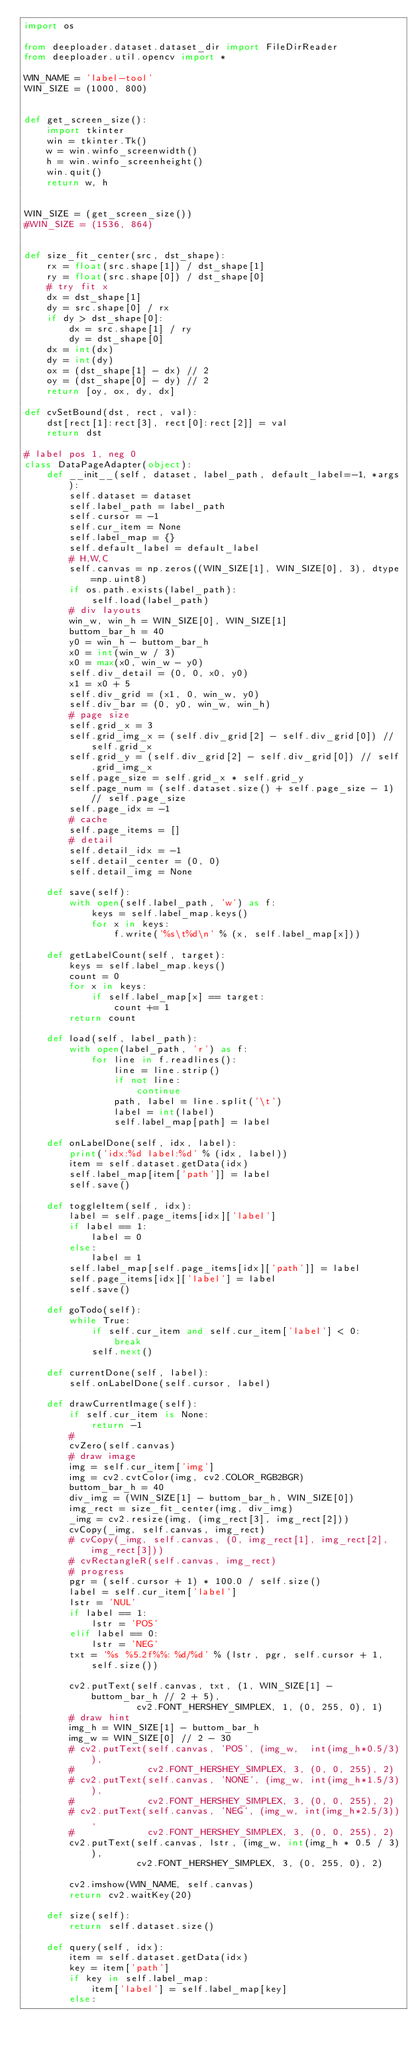Convert code to text. <code><loc_0><loc_0><loc_500><loc_500><_Python_>import os

from deeploader.dataset.dataset_dir import FileDirReader
from deeploader.util.opencv import *

WIN_NAME = 'label-tool'
WIN_SIZE = (1000, 800)


def get_screen_size():
    import tkinter
    win = tkinter.Tk()
    w = win.winfo_screenwidth()
    h = win.winfo_screenheight()
    win.quit()
    return w, h


WIN_SIZE = (get_screen_size())
#WIN_SIZE = (1536, 864)


def size_fit_center(src, dst_shape):
    rx = float(src.shape[1]) / dst_shape[1]
    ry = float(src.shape[0]) / dst_shape[0]
    # try fit x
    dx = dst_shape[1]
    dy = src.shape[0] / rx
    if dy > dst_shape[0]:
        dx = src.shape[1] / ry
        dy = dst_shape[0]
    dx = int(dx)
    dy = int(dy)
    ox = (dst_shape[1] - dx) // 2
    oy = (dst_shape[0] - dy) // 2
    return [oy, ox, dy, dx]

def cvSetBound(dst, rect, val):
    dst[rect[1]:rect[3], rect[0]:rect[2]] = val
    return dst

# label pos 1, neg 0
class DataPageAdapter(object):
    def __init__(self, dataset, label_path, default_label=-1, *args):
        self.dataset = dataset
        self.label_path = label_path
        self.cursor = -1
        self.cur_item = None
        self.label_map = {}
        self.default_label = default_label
        # H,W,C
        self.canvas = np.zeros((WIN_SIZE[1], WIN_SIZE[0], 3), dtype=np.uint8)
        if os.path.exists(label_path):
            self.load(label_path)
        # div layouts
        win_w, win_h = WIN_SIZE[0], WIN_SIZE[1]
        buttom_bar_h = 40
        y0 = win_h - buttom_bar_h
        x0 = int(win_w / 3)
        x0 = max(x0, win_w - y0)
        self.div_detail = (0, 0, x0, y0)
        x1 = x0 + 5
        self.div_grid = (x1, 0, win_w, y0)
        self.div_bar = (0, y0, win_w, win_h)
        # page size
        self.grid_x = 3
        self.grid_img_x = (self.div_grid[2] - self.div_grid[0]) // self.grid_x
        self.grid_y = (self.div_grid[2] - self.div_grid[0]) // self.grid_img_x
        self.page_size = self.grid_x * self.grid_y
        self.page_num = (self.dataset.size() + self.page_size - 1) // self.page_size
        self.page_idx = -1
        # cache
        self.page_items = []
        # detail
        self.detail_idx = -1
        self.detail_center = (0, 0)
        self.detail_img = None

    def save(self):
        with open(self.label_path, 'w') as f:
            keys = self.label_map.keys()
            for x in keys:
                f.write('%s\t%d\n' % (x, self.label_map[x]))

    def getLabelCount(self, target):
        keys = self.label_map.keys()
        count = 0
        for x in keys:
            if self.label_map[x] == target:
                count += 1
        return count

    def load(self, label_path):
        with open(label_path, 'r') as f:
            for line in f.readlines():
                line = line.strip()
                if not line:
                    continue
                path, label = line.split('\t')
                label = int(label)
                self.label_map[path] = label

    def onLabelDone(self, idx, label):
        print('idx:%d label:%d' % (idx, label))
        item = self.dataset.getData(idx)
        self.label_map[item['path']] = label
        self.save()

    def toggleItem(self, idx):
        label = self.page_items[idx]['label']
        if label == 1:
            label = 0
        else:
            label = 1
        self.label_map[self.page_items[idx]['path']] = label
        self.page_items[idx]['label'] = label
        self.save()

    def goTodo(self):
        while True:
            if self.cur_item and self.cur_item['label'] < 0:
                break
            self.next()

    def currentDone(self, label):
        self.onLabelDone(self.cursor, label)

    def drawCurrentImage(self):
        if self.cur_item is None:
            return -1
        #
        cvZero(self.canvas)
        # draw image
        img = self.cur_item['img']
        img = cv2.cvtColor(img, cv2.COLOR_RGB2BGR)
        buttom_bar_h = 40
        div_img = (WIN_SIZE[1] - buttom_bar_h, WIN_SIZE[0])
        img_rect = size_fit_center(img, div_img)
        _img = cv2.resize(img, (img_rect[3], img_rect[2]))
        cvCopy(_img, self.canvas, img_rect)
        # cvCopy(_img, self.canvas, (0, img_rect[1], img_rect[2], img_rect[3]))
        # cvRectangleR(self.canvas, img_rect)
        # progress
        pgr = (self.cursor + 1) * 100.0 / self.size()
        label = self.cur_item['label']
        lstr = 'NUL'
        if label == 1:
            lstr = 'POS'
        elif label == 0:
            lstr = 'NEG'
        txt = '%s %5.2f%%: %d/%d' % (lstr, pgr, self.cursor + 1, self.size())

        cv2.putText(self.canvas, txt, (1, WIN_SIZE[1] - buttom_bar_h // 2 + 5),
                    cv2.FONT_HERSHEY_SIMPLEX, 1, (0, 255, 0), 1)
        # draw hint
        img_h = WIN_SIZE[1] - buttom_bar_h
        img_w = WIN_SIZE[0] // 2 - 30
        # cv2.putText(self.canvas, 'POS', (img_w,  int(img_h*0.5/3)),
        #             cv2.FONT_HERSHEY_SIMPLEX, 3, (0, 0, 255), 2)
        # cv2.putText(self.canvas, 'NONE', (img_w, int(img_h*1.5/3)),
        #             cv2.FONT_HERSHEY_SIMPLEX, 3, (0, 0, 255), 2)
        # cv2.putText(self.canvas, 'NEG', (img_w, int(img_h*2.5/3)),
        #             cv2.FONT_HERSHEY_SIMPLEX, 3, (0, 0, 255), 2)
        cv2.putText(self.canvas, lstr, (img_w, int(img_h * 0.5 / 3)),
                    cv2.FONT_HERSHEY_SIMPLEX, 3, (0, 255, 0), 2)

        cv2.imshow(WIN_NAME, self.canvas)
        return cv2.waitKey(20)

    def size(self):
        return self.dataset.size()

    def query(self, idx):
        item = self.dataset.getData(idx)
        key = item['path']
        if key in self.label_map:
            item['label'] = self.label_map[key]
        else:</code> 